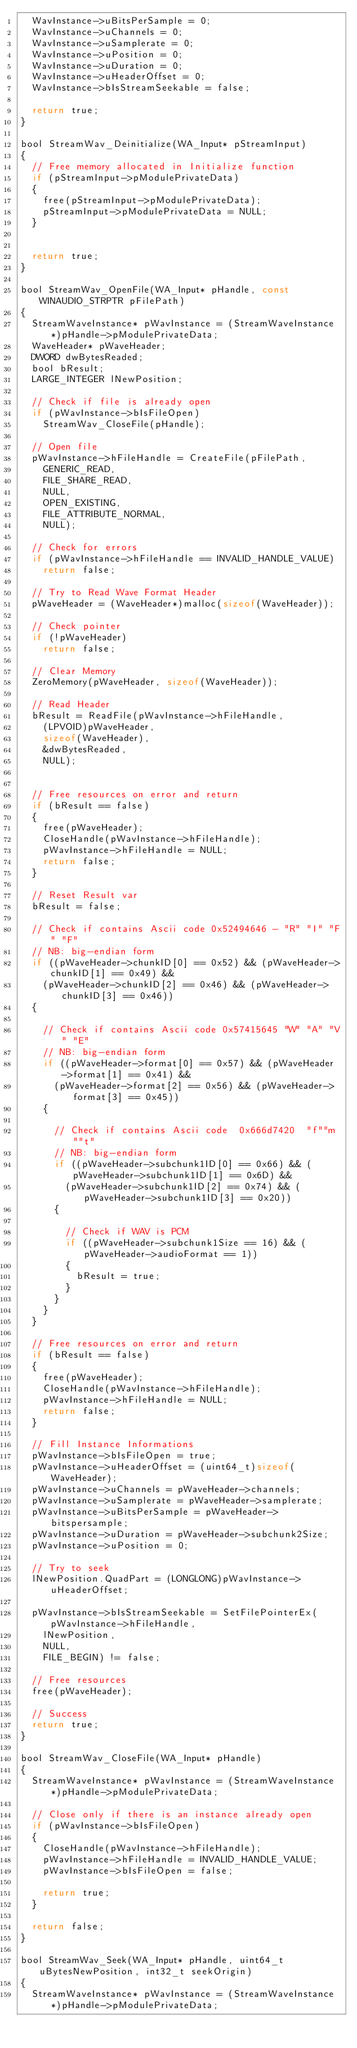Convert code to text. <code><loc_0><loc_0><loc_500><loc_500><_C_>	WavInstance->uBitsPerSample = 0;
	WavInstance->uChannels = 0;
	WavInstance->uSamplerate = 0;
	WavInstance->uPosition = 0;
	WavInstance->uDuration = 0;
	WavInstance->uHeaderOffset = 0;
	WavInstance->bIsStreamSeekable = false;

	return true;
}

bool StreamWav_Deinitialize(WA_Input* pStreamInput)
{
	// Free memory allocated in Initialize function
	if (pStreamInput->pModulePrivateData)
	{
		free(pStreamInput->pModulePrivateData);
		pStreamInput->pModulePrivateData = NULL;
	}


	return true;
}

bool StreamWav_OpenFile(WA_Input* pHandle, const WINAUDIO_STRPTR pFilePath)
{
	StreamWaveInstance* pWavInstance = (StreamWaveInstance*)pHandle->pModulePrivateData;
	WaveHeader* pWaveHeader;
	DWORD dwBytesReaded;
	bool bResult;
	LARGE_INTEGER lNewPosition;

	// Check if file is already open
	if (pWavInstance->bIsFileOpen)
		StreamWav_CloseFile(pHandle);

	// Open file
	pWavInstance->hFileHandle = CreateFile(pFilePath,
		GENERIC_READ,
		FILE_SHARE_READ,
		NULL,
		OPEN_EXISTING,
		FILE_ATTRIBUTE_NORMAL,
		NULL);

	// Check for errors
	if (pWavInstance->hFileHandle == INVALID_HANDLE_VALUE)
		return false;

	// Try to Read Wave Format Header
	pWaveHeader = (WaveHeader*)malloc(sizeof(WaveHeader));

	// Check pointer
	if (!pWaveHeader)
		return false;

	// Clear Memory
	ZeroMemory(pWaveHeader, sizeof(WaveHeader));

	// Read Header
	bResult = ReadFile(pWavInstance->hFileHandle,
		(LPVOID)pWaveHeader,
		sizeof(WaveHeader),
		&dwBytesReaded,
		NULL);


	// Free resources on error and return
	if (bResult == false)
	{
		free(pWaveHeader);
		CloseHandle(pWavInstance->hFileHandle);
		pWavInstance->hFileHandle = NULL;
		return false;
	}

	// Reset Result var
	bResult = false;

	// Check if contains Ascii code 0x52494646 - "R" "I" "F" "F" 
	// NB: big-endian form
	if ((pWaveHeader->chunkID[0] == 0x52) && (pWaveHeader->chunkID[1] == 0x49) &&
		(pWaveHeader->chunkID[2] == 0x46) && (pWaveHeader->chunkID[3] == 0x46))
	{

		// Check if contains Ascii code 0x57415645 "W" "A" "V" "E"
		// NB: big-endian form
		if ((pWaveHeader->format[0] == 0x57) && (pWaveHeader->format[1] == 0x41) &&
			(pWaveHeader->format[2] == 0x56) && (pWaveHeader->format[3] == 0x45))
		{

			// Check if contains Ascii code  0x666d7420  "f""m""t"
			// NB: big-endian form
			if ((pWaveHeader->subchunk1ID[0] == 0x66) && (pWaveHeader->subchunk1ID[1] == 0x6D) &&
				(pWaveHeader->subchunk1ID[2] == 0x74) && (pWaveHeader->subchunk1ID[3] == 0x20))
			{

				// Check if WAV is PCM
				if ((pWaveHeader->subchunk1Size == 16) && (pWaveHeader->audioFormat == 1))
				{
					bResult = true;
				}
			}
		}
	}

	// Free resources on error and return
	if (bResult == false)
	{
		free(pWaveHeader);
		CloseHandle(pWavInstance->hFileHandle);
		pWavInstance->hFileHandle = NULL;
		return false;
	}

	// Fill Instance Informations
	pWavInstance->bIsFileOpen = true;
	pWavInstance->uHeaderOffset = (uint64_t)sizeof(WaveHeader);
	pWavInstance->uChannels = pWaveHeader->channels;
	pWavInstance->uSamplerate = pWaveHeader->samplerate;
	pWavInstance->uBitsPerSample = pWaveHeader->bitspersample;
	pWavInstance->uDuration = pWaveHeader->subchunk2Size;
	pWavInstance->uPosition = 0;

	// Try to seek
	lNewPosition.QuadPart = (LONGLONG)pWavInstance->uHeaderOffset;

	pWavInstance->bIsStreamSeekable = SetFilePointerEx(pWavInstance->hFileHandle,
		lNewPosition,
		NULL,
		FILE_BEGIN) != false;

	// Free resources
	free(pWaveHeader);

	// Success
	return true;
}

bool StreamWav_CloseFile(WA_Input* pHandle)
{
	StreamWaveInstance* pWavInstance = (StreamWaveInstance*)pHandle->pModulePrivateData;

	// Close only if there is an instance already open
	if (pWavInstance->bIsFileOpen)
	{
		CloseHandle(pWavInstance->hFileHandle);
		pWavInstance->hFileHandle = INVALID_HANDLE_VALUE;
		pWavInstance->bIsFileOpen = false;

		return true;
	}

	return false;
}

bool StreamWav_Seek(WA_Input* pHandle, uint64_t uBytesNewPosition, int32_t seekOrigin)
{
	StreamWaveInstance* pWavInstance = (StreamWaveInstance*)pHandle->pModulePrivateData;</code> 